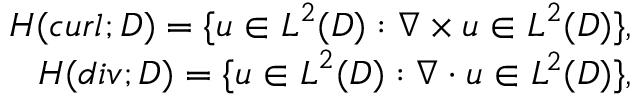<formula> <loc_0><loc_0><loc_500><loc_500>\begin{array} { r l r } & { H ( c u r l ; D ) = \{ u \in L ^ { 2 } ( D ) \colon \nabla \times u \in L ^ { 2 } ( D ) \} , } \\ & { H ( d i v ; D ) = \{ u \in L ^ { 2 } ( D ) \colon \nabla \cdot u \in L ^ { 2 } ( D ) \} , } \end{array}</formula> 